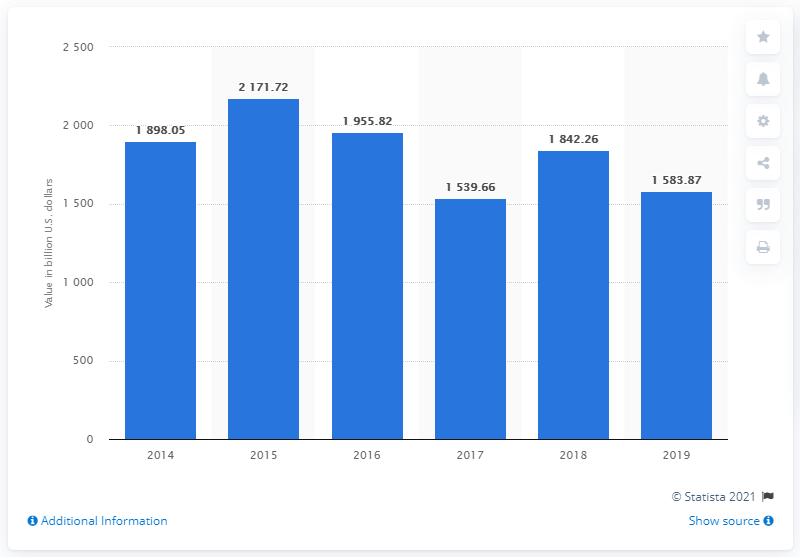Give some essential details in this illustration. According to data from 2019, the value of mergers and acquisitions (M&A) deals in the United States was 1,583.87. 